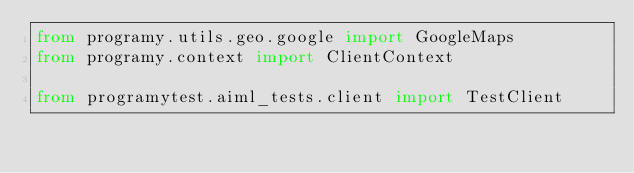Convert code to text. <code><loc_0><loc_0><loc_500><loc_500><_Python_>from programy.utils.geo.google import GoogleMaps
from programy.context import ClientContext

from programytest.aiml_tests.client import TestClient

</code> 